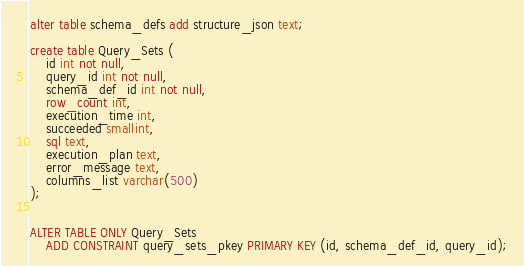<code> <loc_0><loc_0><loc_500><loc_500><_SQL_>alter table schema_defs add structure_json text;

create table Query_Sets (
	id int not null,
	query_id int not null,
	schema_def_id int not null,
	row_count int,
	execution_time int,
	succeeded smallint,
	sql text,
	execution_plan text,
	error_message text,
	columns_list varchar(500)
);


ALTER TABLE ONLY Query_Sets
    ADD CONSTRAINT query_sets_pkey PRIMARY KEY (id, schema_def_id, query_id);
</code> 